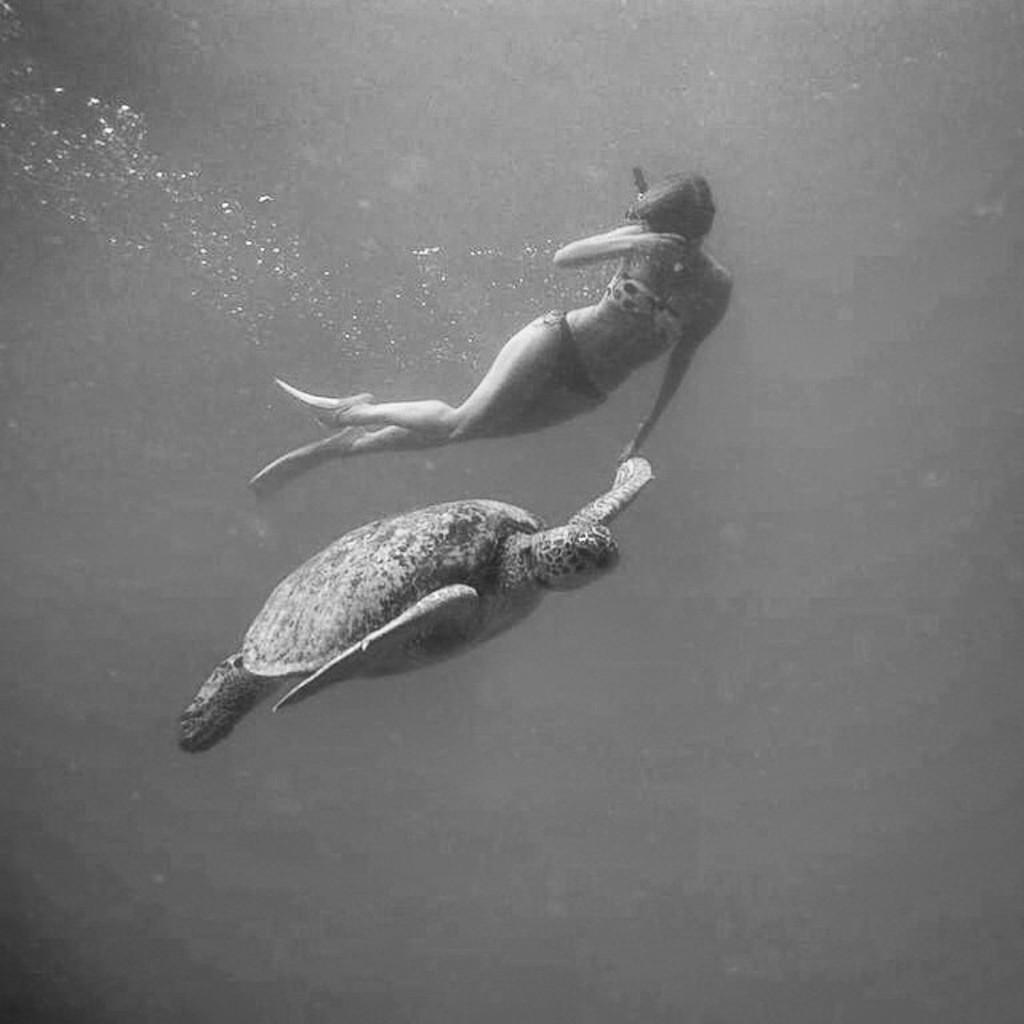In one or two sentences, can you explain what this image depicts? This is an black and white image. In this image we can see woman and turtle under the water. 